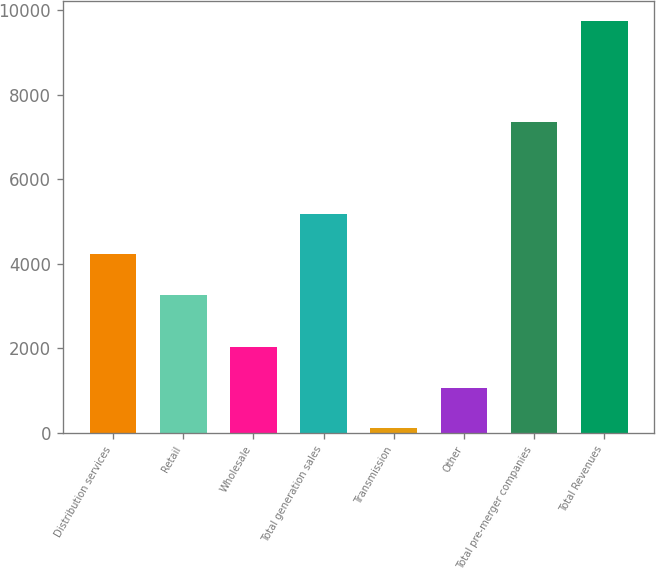Convert chart to OTSL. <chart><loc_0><loc_0><loc_500><loc_500><bar_chart><fcel>Distribution services<fcel>Retail<fcel>Wholesale<fcel>Total generation sales<fcel>Transmission<fcel>Other<fcel>Total pre-merger companies<fcel>Total Revenues<nl><fcel>4229<fcel>3266<fcel>2036<fcel>5192<fcel>110<fcel>1073<fcel>7361<fcel>9740<nl></chart> 